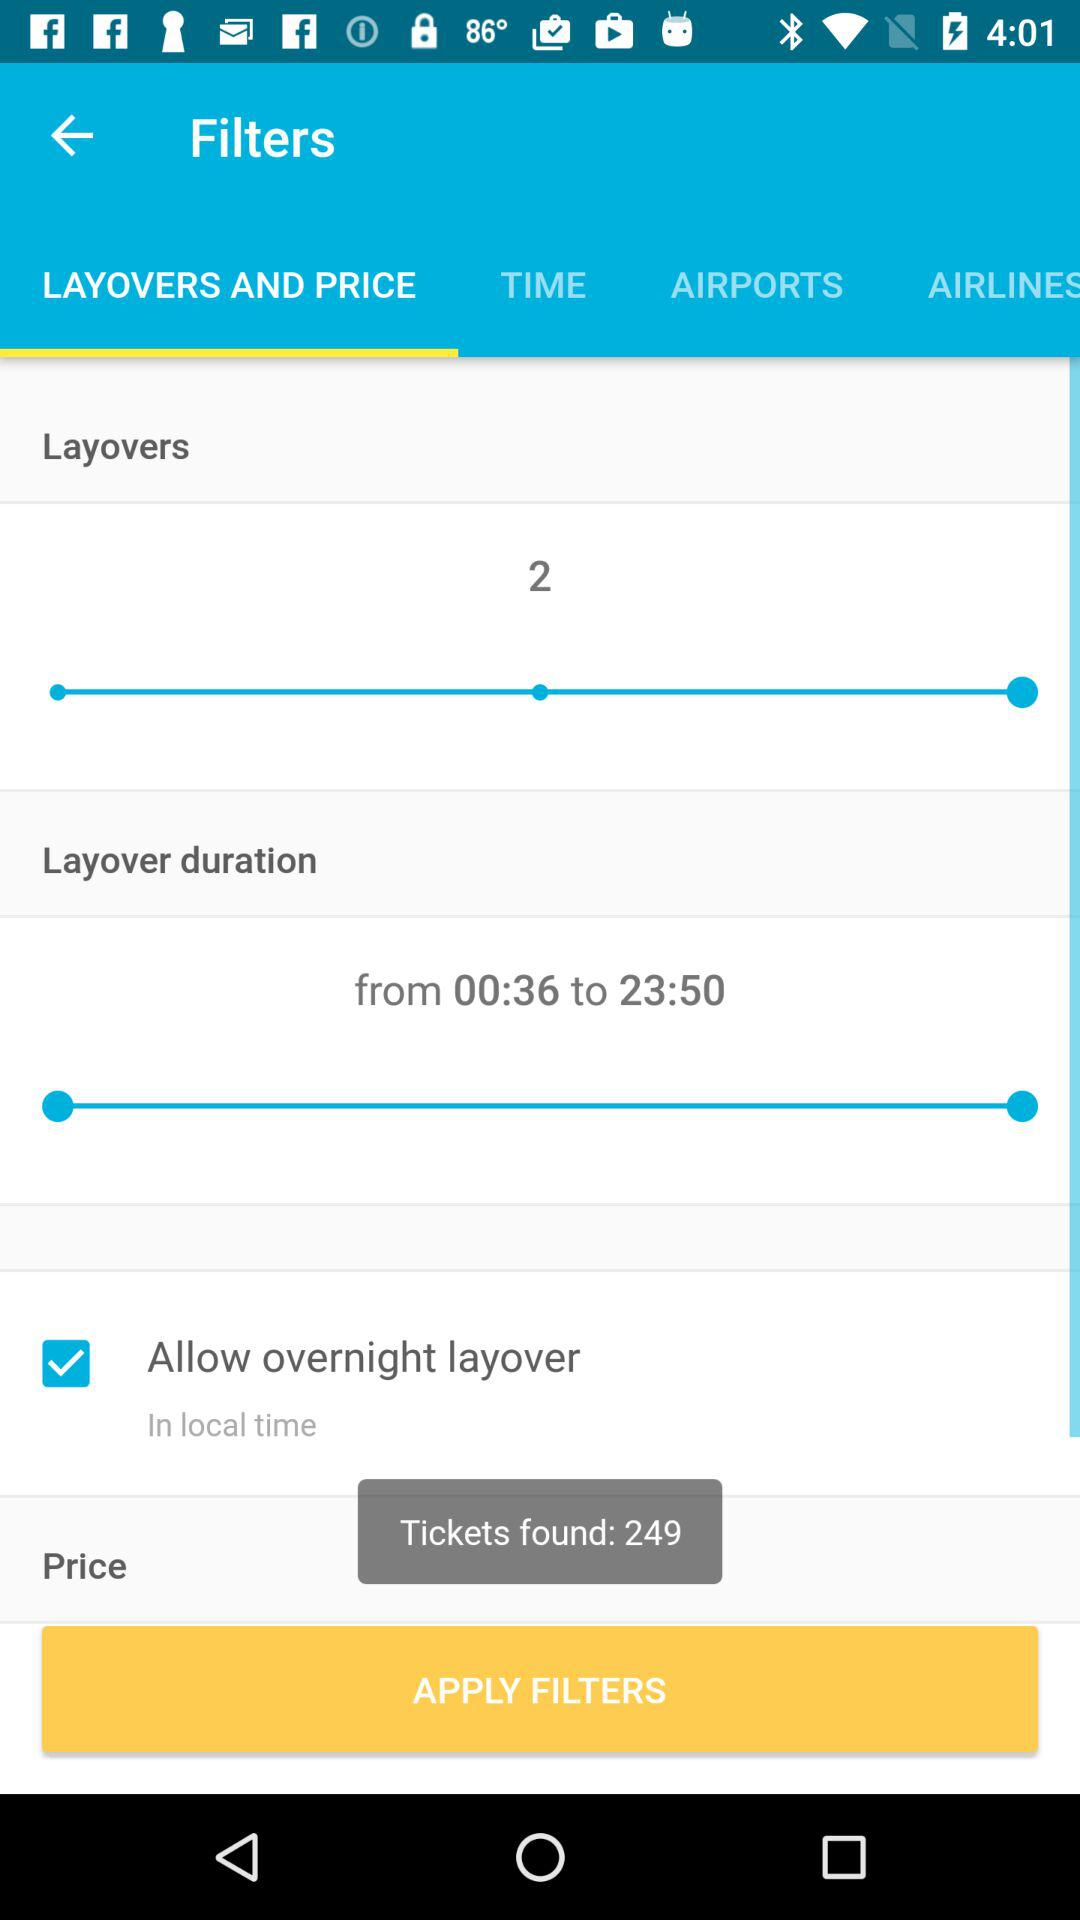How many layovers are included in the shortest flight?
Answer the question using a single word or phrase. 2 